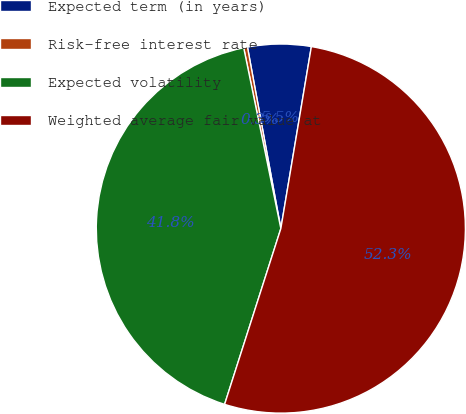Convert chart. <chart><loc_0><loc_0><loc_500><loc_500><pie_chart><fcel>Expected term (in years)<fcel>Risk-free interest rate<fcel>Expected volatility<fcel>Weighted average fair value at<nl><fcel>5.54%<fcel>0.33%<fcel>41.85%<fcel>52.29%<nl></chart> 